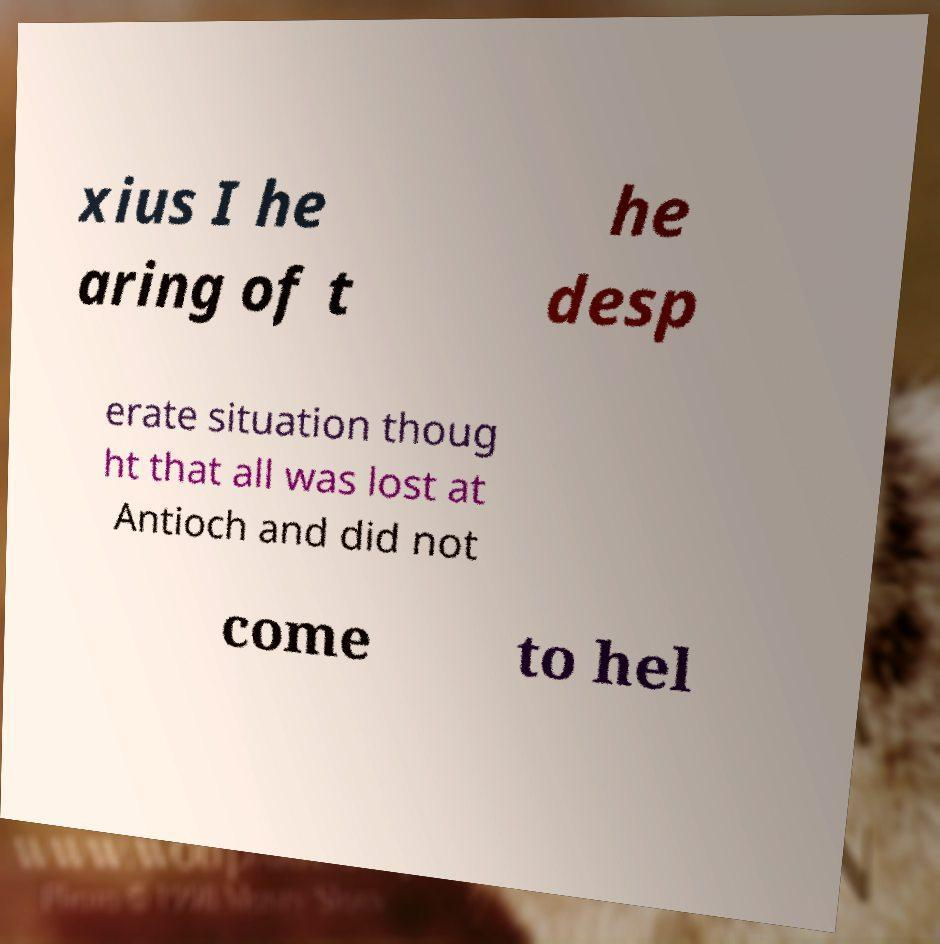Can you accurately transcribe the text from the provided image for me? xius I he aring of t he desp erate situation thoug ht that all was lost at Antioch and did not come to hel 